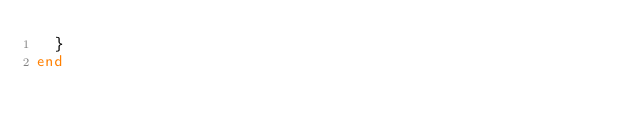Convert code to text. <code><loc_0><loc_0><loc_500><loc_500><_Ruby_>  }
end
</code> 